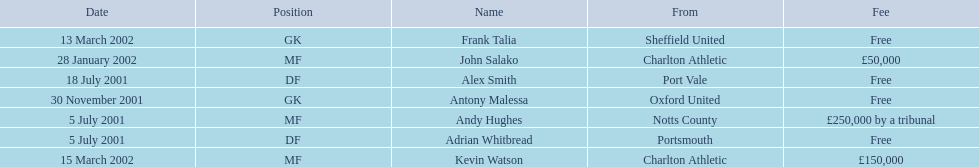What is the total number of free fees? 4. 